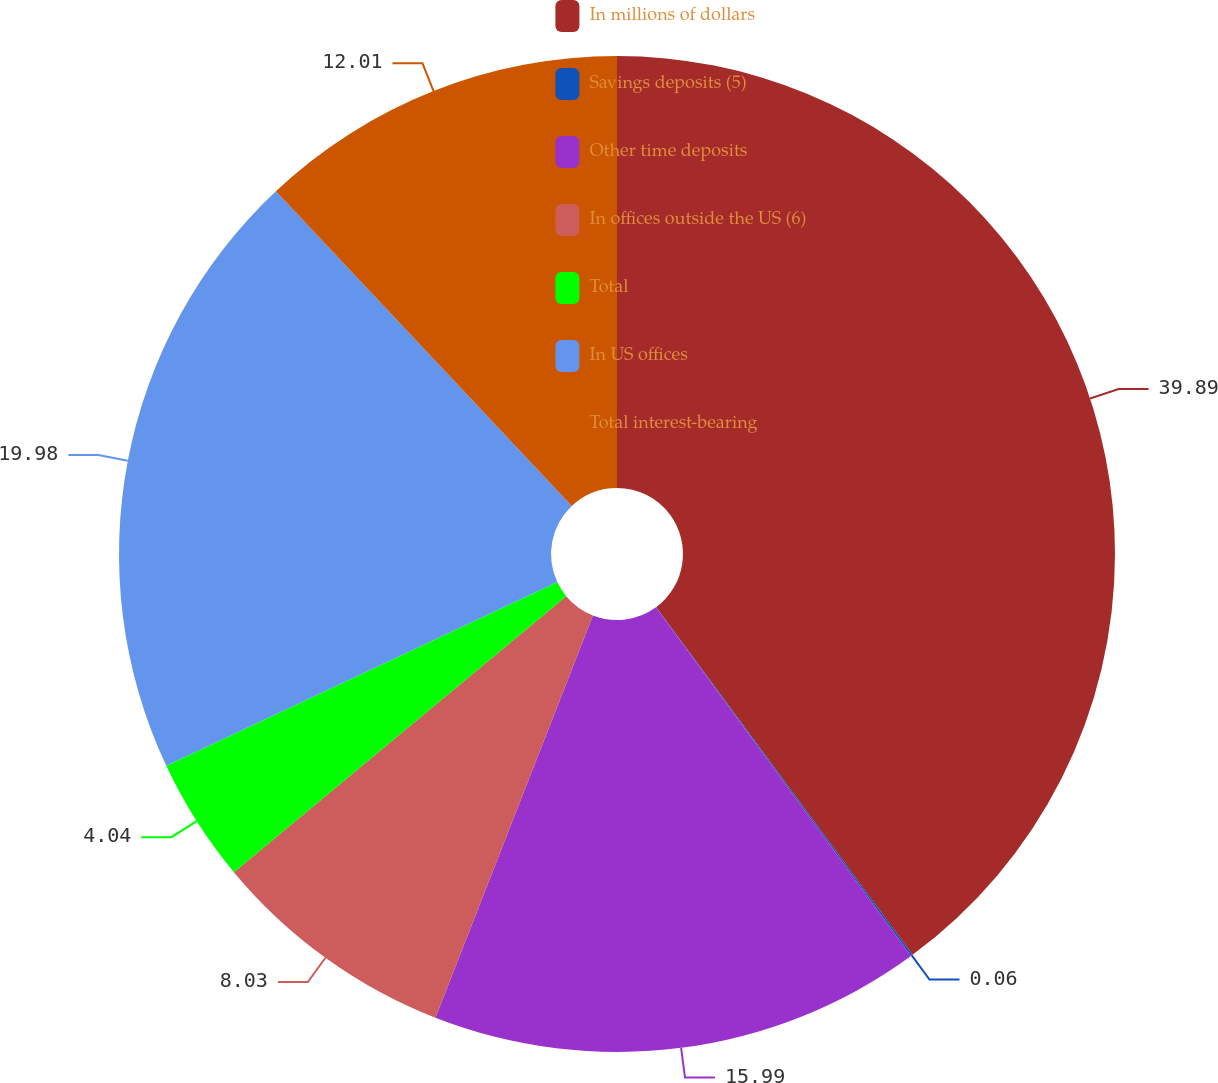<chart> <loc_0><loc_0><loc_500><loc_500><pie_chart><fcel>In millions of dollars<fcel>Savings deposits (5)<fcel>Other time deposits<fcel>In offices outside the US (6)<fcel>Total<fcel>In US offices<fcel>Total interest-bearing<nl><fcel>39.89%<fcel>0.06%<fcel>15.99%<fcel>8.03%<fcel>4.04%<fcel>19.98%<fcel>12.01%<nl></chart> 